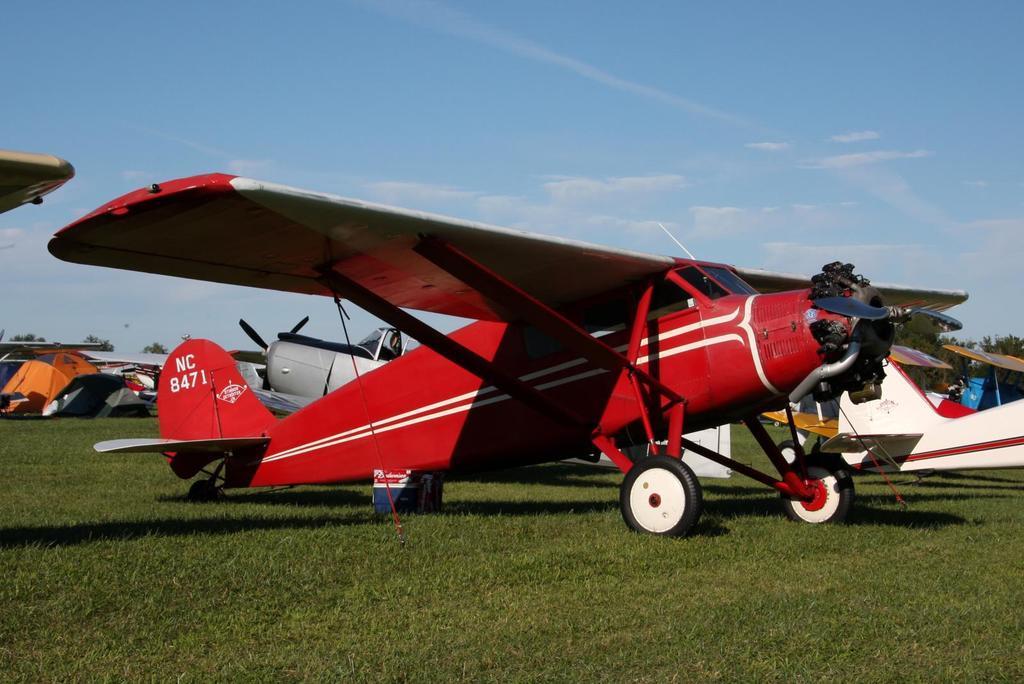Describe this image in one or two sentences. In this image I can see a red color flight visible on the ground and I can see a aircraft on the right side and I can see the sky at the top. 